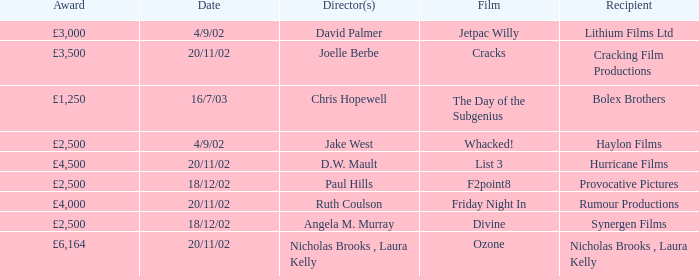What award did the film Ozone win? £6,164. 